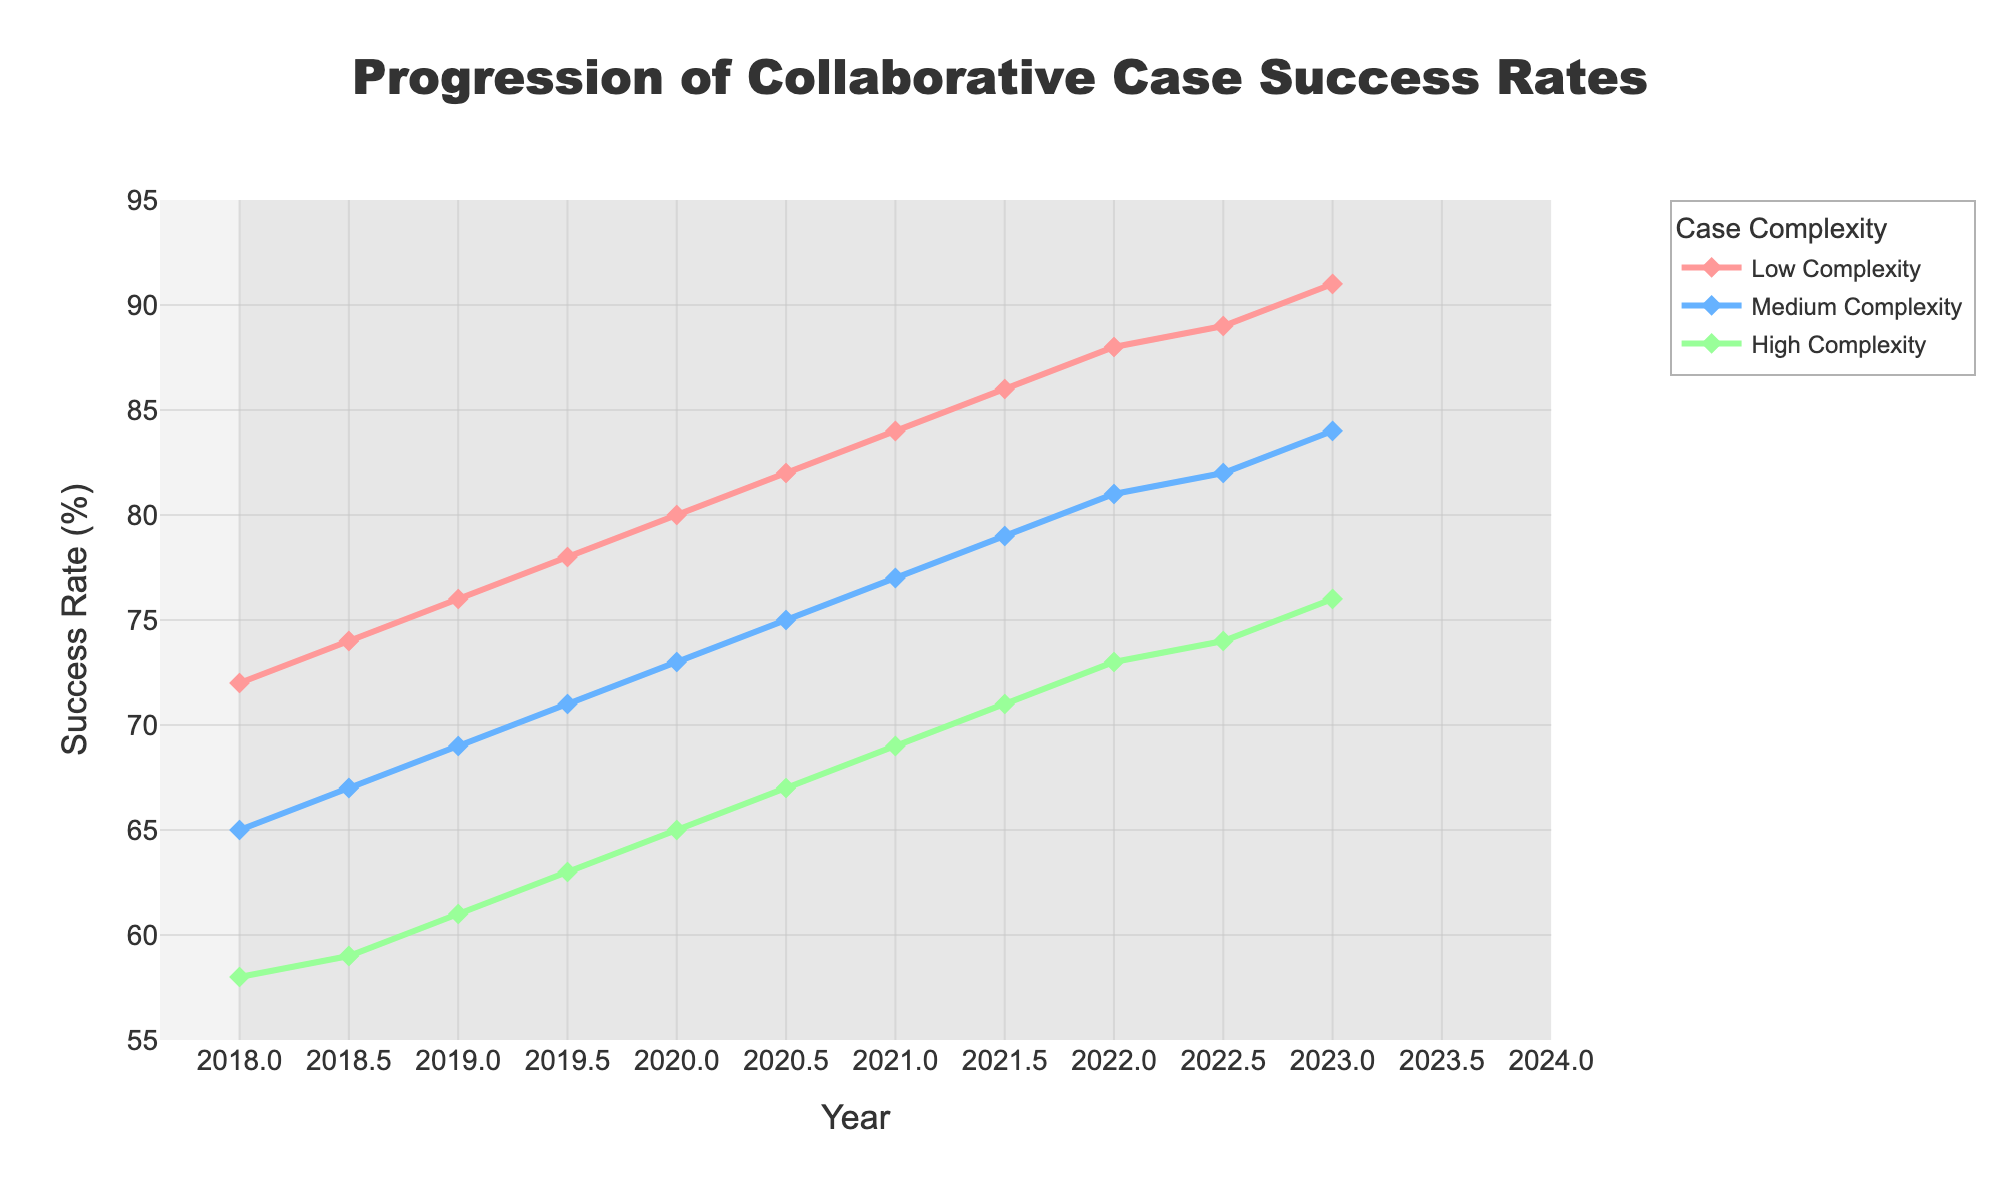What are the success rates for low, medium, and high complexity cases in 2023? Looking at the figure, locate the year 2023 on the x-axis, then identify the success rates for low, medium, and high complexity cases.
Answer: 91%, 84%, 76% Between 2018 and 2023, which case complexity showed the highest average improvement in success rates? To determine this, calculate the success rate improvement for each complexity from 2018 to 2023, then find the average improvement. Low: 91-72=19, Medium: 84-65=19, High: 76-58=18. The average improvements are: Low=19/5 years, Medium=19/5 years, High=18/5 years. Both Low and Medium complexity cases had the highest average improvement.
Answer: Low and Medium Complexity How has the success rate for medium complexity cases changed from 2020 to 2021? Locate the years 2020 and 2021 on the x-axis, then find the success rates for medium complexity cases. Subtract the 2020 value from the 2021 value: 77 - 73 = 4%.
Answer: 4% Which year saw the highest increase in success rates for high complexity cases? To determine this, find the success rates for high complexity cases for each year and calculate the annual increase. Compare the increases to find the highest one. Between 2022 (73%) and 2022.5 (74%) is an increase of 1%.
Answer: 2018.5 to 2019 Between 2018 and 2021, was the success rate for low complexity cases ever lower than that for medium complexity cases? Compare the success rates for low complexity and medium complexity cases year by year between 2018 and 2021 to see if the low complexity rate was ever lower. You will see that the low complexity rate was always higher.
Answer: No By how much did the success rate of low complexity cases increase from mid-2018 to mid-2023? Identify the success rates for low complexity cases in 2018.5 and 2023 on the x-axis, then subtract the former from the latter: 91 - 74 = 17%.
Answer: 17% Compare the success rate trends for medium and high complexity cases between 2020 and 2022. Look at the success rate lines for medium and high complexity cases between 2020 and 2022 on the x-axis. Both show a generally increasing trend, but medium complexity shows a steeper increase.
Answer: Both increased, but medium complexity increased more In which year did the success rate of low complexity cases cross 80% for the first time? Locate the year on the x-axis where the success rate for low complexity cases first crosses the 80% mark. This occurs between 2020 and 2020.5.
Answer: 2020.5 What is the difference in success rates between low and high complexity cases in 2022? Identify success rates for low and high complexity cases in 2022 on the x-axis, then subtract the high complexity rate from the low complexity rate: 88 - 73 = 15%.
Answer: 15% Between 2018 and 2023, which complexity shows the most consistent rate of increase in success rates? Observe the trends of the success rate lines for each complexity from 2018 to 2023. The most consistent rate is the one with the smoothest, most steady upward trend, which can be visually assessed.
Answer: Low Complexity 